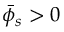Convert formula to latex. <formula><loc_0><loc_0><loc_500><loc_500>\bar { \phi } _ { s } > 0</formula> 